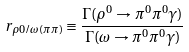Convert formula to latex. <formula><loc_0><loc_0><loc_500><loc_500>r _ { \rho 0 / \omega ( \pi \pi ) } \equiv \frac { \Gamma ( \rho ^ { 0 } \to \pi ^ { 0 } \pi ^ { 0 } \gamma ) } { \Gamma ( \omega \to \pi ^ { 0 } \pi ^ { 0 } \gamma ) }</formula> 